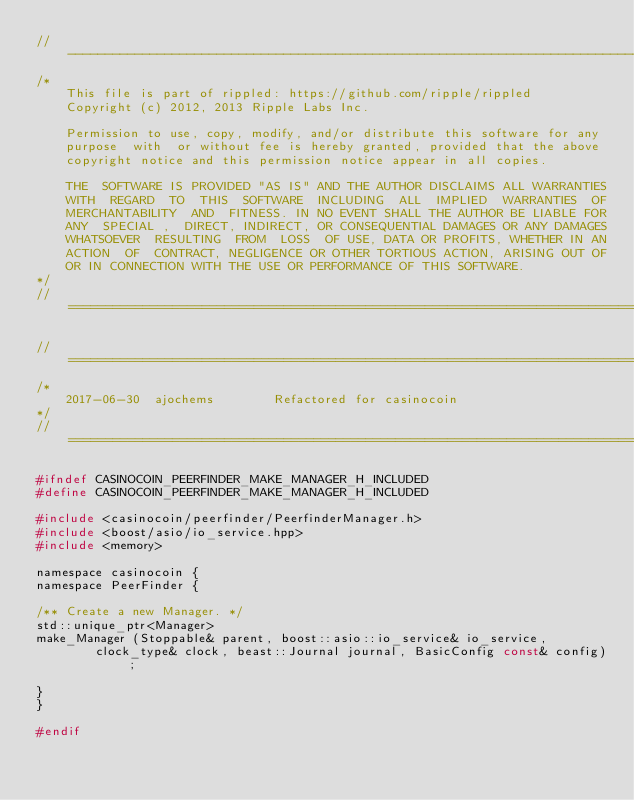Convert code to text. <code><loc_0><loc_0><loc_500><loc_500><_C_>//------------------------------------------------------------------------------
/*
    This file is part of rippled: https://github.com/ripple/rippled
    Copyright (c) 2012, 2013 Ripple Labs Inc.

    Permission to use, copy, modify, and/or distribute this software for any
    purpose  with  or without fee is hereby granted, provided that the above
    copyright notice and this permission notice appear in all copies.

    THE  SOFTWARE IS PROVIDED "AS IS" AND THE AUTHOR DISCLAIMS ALL WARRANTIES
    WITH  REGARD  TO  THIS  SOFTWARE  INCLUDING  ALL  IMPLIED  WARRANTIES  OF
    MERCHANTABILITY  AND  FITNESS. IN NO EVENT SHALL THE AUTHOR BE LIABLE FOR
    ANY  SPECIAL ,  DIRECT, INDIRECT, OR CONSEQUENTIAL DAMAGES OR ANY DAMAGES
    WHATSOEVER  RESULTING  FROM  LOSS  OF USE, DATA OR PROFITS, WHETHER IN AN
    ACTION  OF  CONTRACT, NEGLIGENCE OR OTHER TORTIOUS ACTION, ARISING OUT OF
    OR IN CONNECTION WITH THE USE OR PERFORMANCE OF THIS SOFTWARE.
*/
//==============================================================================

//==============================================================================
/*
    2017-06-30  ajochems        Refactored for casinocoin
*/
//==============================================================================

#ifndef CASINOCOIN_PEERFINDER_MAKE_MANAGER_H_INCLUDED
#define CASINOCOIN_PEERFINDER_MAKE_MANAGER_H_INCLUDED

#include <casinocoin/peerfinder/PeerfinderManager.h>
#include <boost/asio/io_service.hpp>
#include <memory>

namespace casinocoin {
namespace PeerFinder {

/** Create a new Manager. */
std::unique_ptr<Manager>
make_Manager (Stoppable& parent, boost::asio::io_service& io_service,
        clock_type& clock, beast::Journal journal, BasicConfig const& config);

}
}

#endif
</code> 